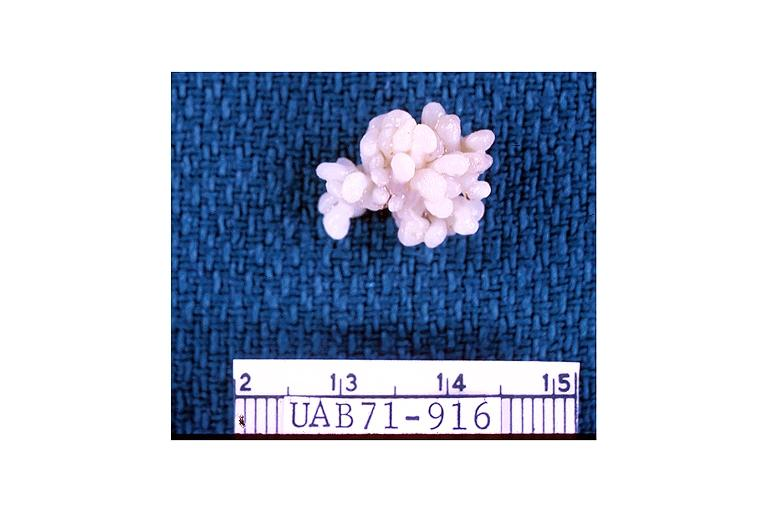where is this?
Answer the question using a single word or phrase. Oral 